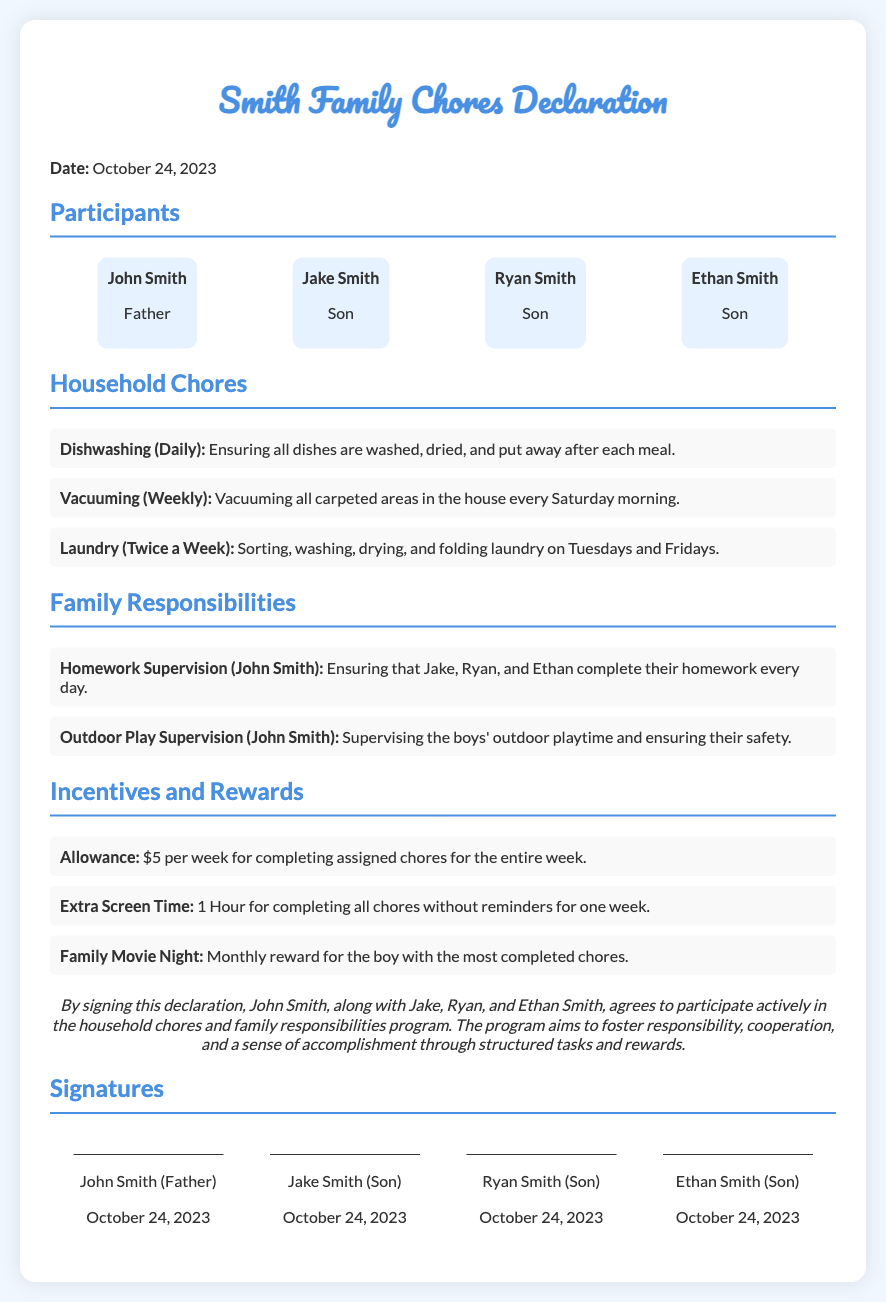What is the date of the declaration? The date is specified in the document at the top.
Answer: October 24, 2023 Who is the father in the document? The document lists participants, including the father.
Answer: John Smith How many sons are listed in the declaration? The number of sons can be counted from the participants section.
Answer: Three What is one of the chores to be completed daily? The chores are listed under "Household Chores" in a bulleted format.
Answer: Dishwashing What is the reward for the boy with the most completed chores? The rewards are outlined in the "Incentives and Rewards" section.
Answer: Family Movie Night What is the allowance provided per week for chores? The amount of allowance is mentioned in the "Incentives and Rewards" section.
Answer: $5 What responsibility does John Smith have related to homework? The responsibilities section specifies what John Smith supervises.
Answer: Homework Supervision How often is laundry supposed to be done? The frequency of laundry days is included in the chores section.
Answer: Twice a Week What is required for one hour of extra screen time? The condition for earning extra screen time is stated in the incentives section.
Answer: Completing all chores without reminders for one week 